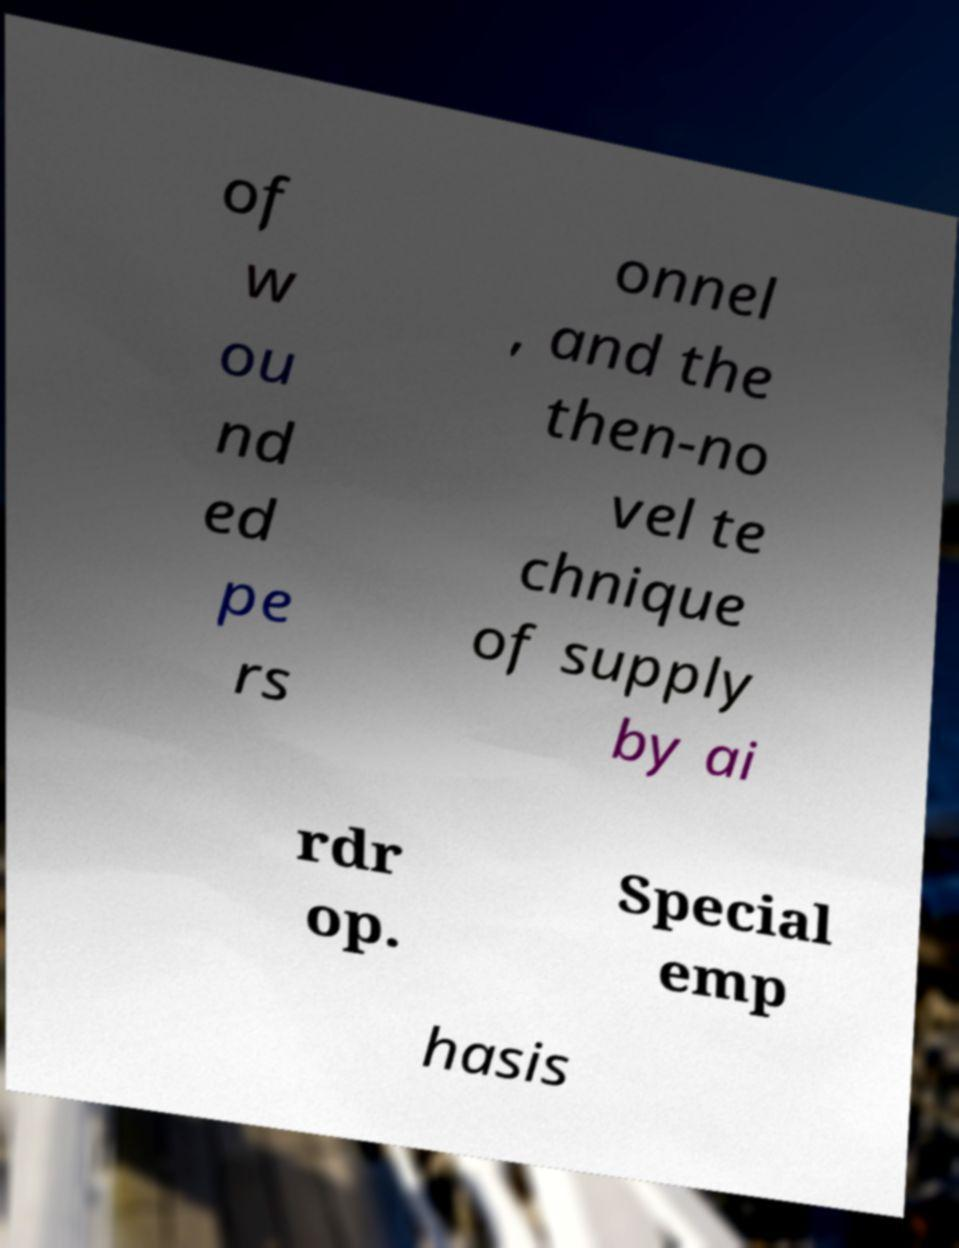Could you assist in decoding the text presented in this image and type it out clearly? of w ou nd ed pe rs onnel , and the then-no vel te chnique of supply by ai rdr op. Special emp hasis 